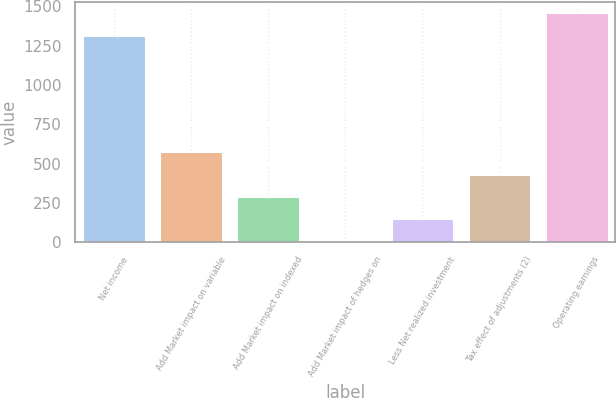Convert chart to OTSL. <chart><loc_0><loc_0><loc_500><loc_500><bar_chart><fcel>Net income<fcel>Add Market impact on variable<fcel>Add Market impact on indexed<fcel>Add Market impact of hedges on<fcel>Less Net realized investment<fcel>Tax effect of adjustments (2)<fcel>Operating earnings<nl><fcel>1314<fcel>572.6<fcel>287.8<fcel>3<fcel>145.4<fcel>430.2<fcel>1456.4<nl></chart> 